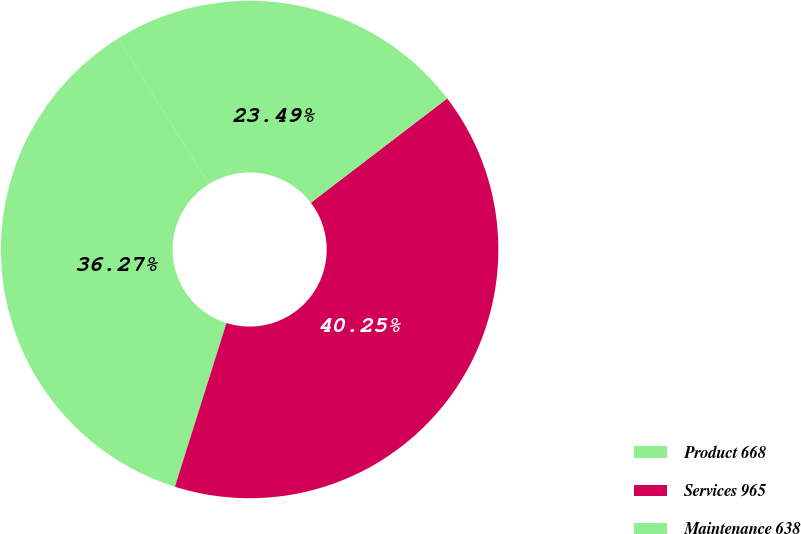<chart> <loc_0><loc_0><loc_500><loc_500><pie_chart><fcel>Product 668<fcel>Services 965<fcel>Maintenance 638<nl><fcel>36.27%<fcel>40.25%<fcel>23.49%<nl></chart> 